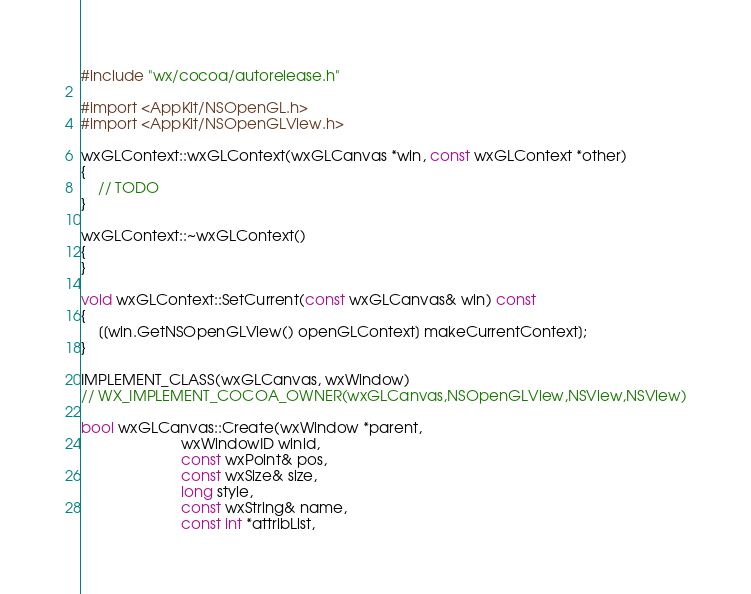<code> <loc_0><loc_0><loc_500><loc_500><_ObjectiveC_>#include "wx/cocoa/autorelease.h"

#import <AppKit/NSOpenGL.h>
#import <AppKit/NSOpenGLView.h>

wxGLContext::wxGLContext(wxGLCanvas *win, const wxGLContext *other)
{
    // TODO
}

wxGLContext::~wxGLContext()
{
}

void wxGLContext::SetCurrent(const wxGLCanvas& win) const
{
    [[win.GetNSOpenGLView() openGLContext] makeCurrentContext];
}

IMPLEMENT_CLASS(wxGLCanvas, wxWindow)
// WX_IMPLEMENT_COCOA_OWNER(wxGLCanvas,NSOpenGLView,NSView,NSView)

bool wxGLCanvas::Create(wxWindow *parent,
                        wxWindowID winid,
                        const wxPoint& pos,
                        const wxSize& size,
                        long style,
                        const wxString& name,
                        const int *attribList,</code> 